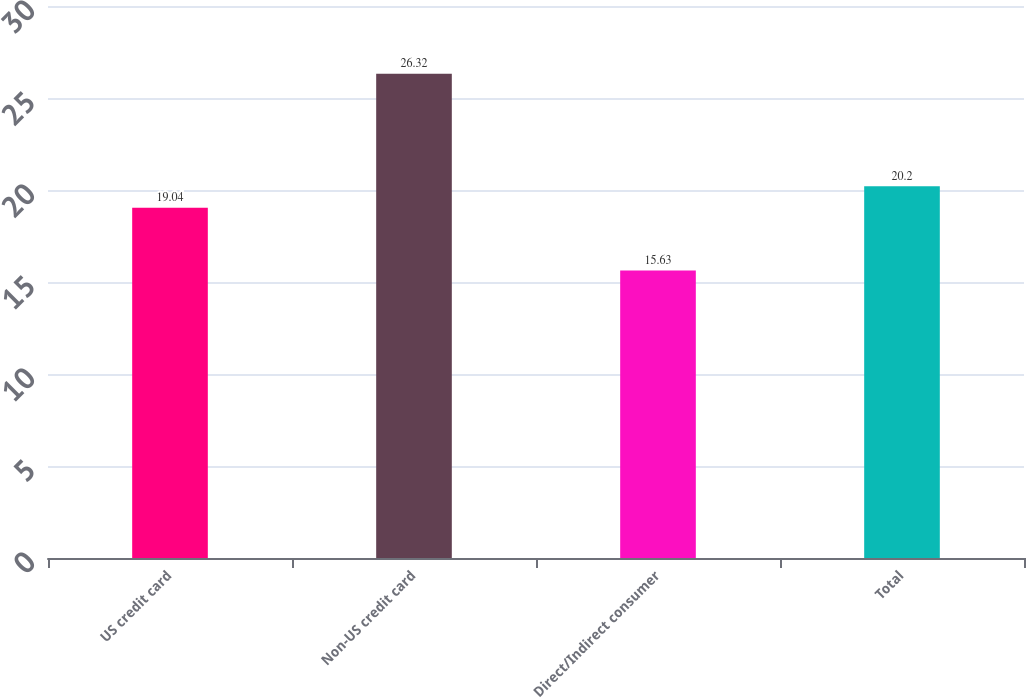Convert chart to OTSL. <chart><loc_0><loc_0><loc_500><loc_500><bar_chart><fcel>US credit card<fcel>Non-US credit card<fcel>Direct/Indirect consumer<fcel>Total<nl><fcel>19.04<fcel>26.32<fcel>15.63<fcel>20.2<nl></chart> 